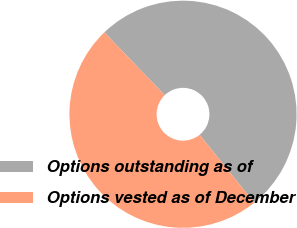Convert chart. <chart><loc_0><loc_0><loc_500><loc_500><pie_chart><fcel>Options outstanding as of<fcel>Options vested as of December<nl><fcel>51.39%<fcel>48.61%<nl></chart> 